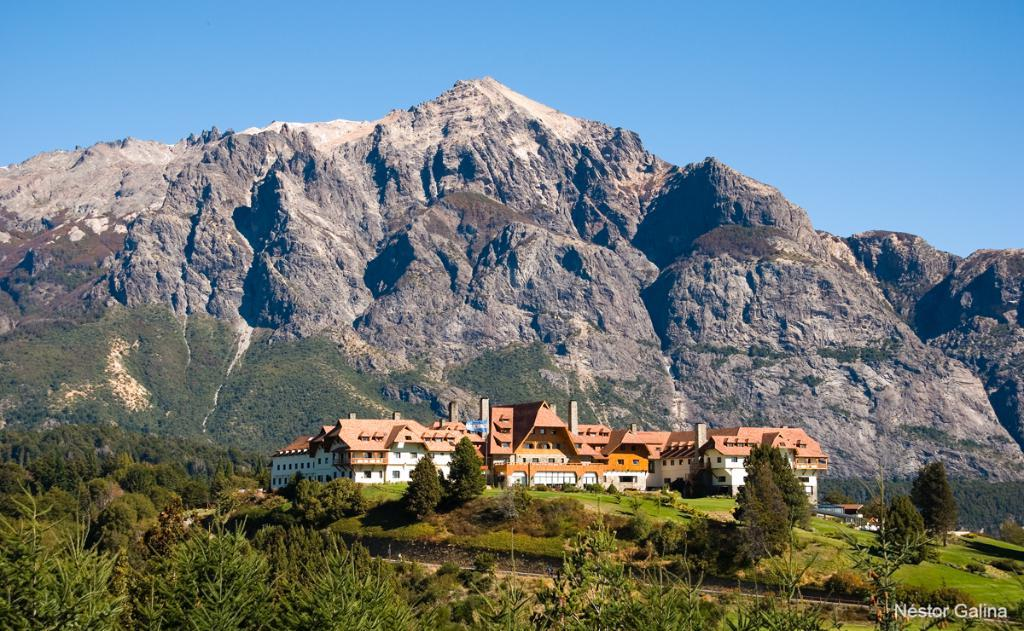What is the main structure in the image? There is a house in the middle of the image. What type of natural features can be seen in the image? Mountains, trees, and plants are present in the image. How many yaks are grazing in the image? There are no yaks present in the image. What type of lumber is being used to construct the house in the image? The image does not provide information about the construction materials of the house. 